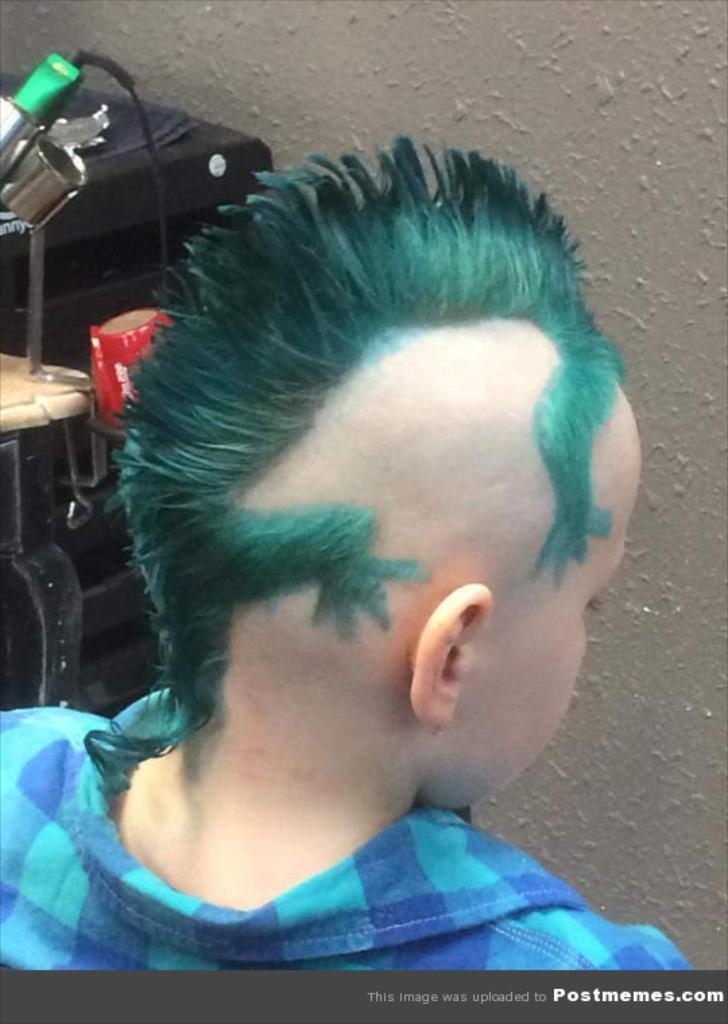Who is the main subject in the image? There is a boy in the image. What can be seen beside the boy? There are objects beside the boy. What is in front of the boy? There is a wall in front of the boy. What is written or displayed at the bottom of the image? There is some text at the bottom of the image. Are there any icicles hanging from the wall in the image? There are no icicles visible in the image. What type of rod can be seen being used by the boy in the image? There is no rod being used by the boy in the image. 